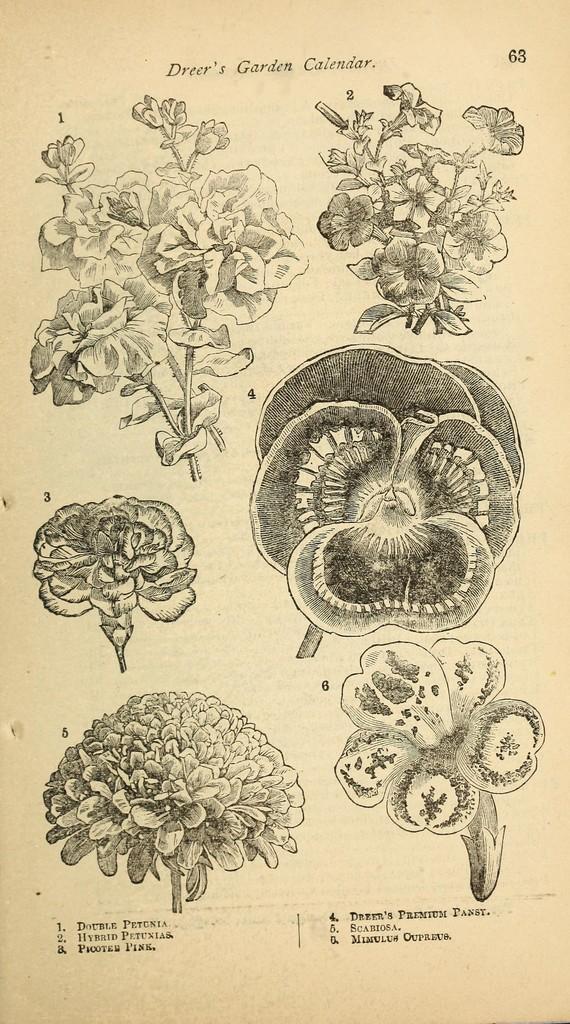In one or two sentences, can you explain what this image depicts? In this image I can see many flowers and something is written on the paper. I can see the paper is in black and cream color. 